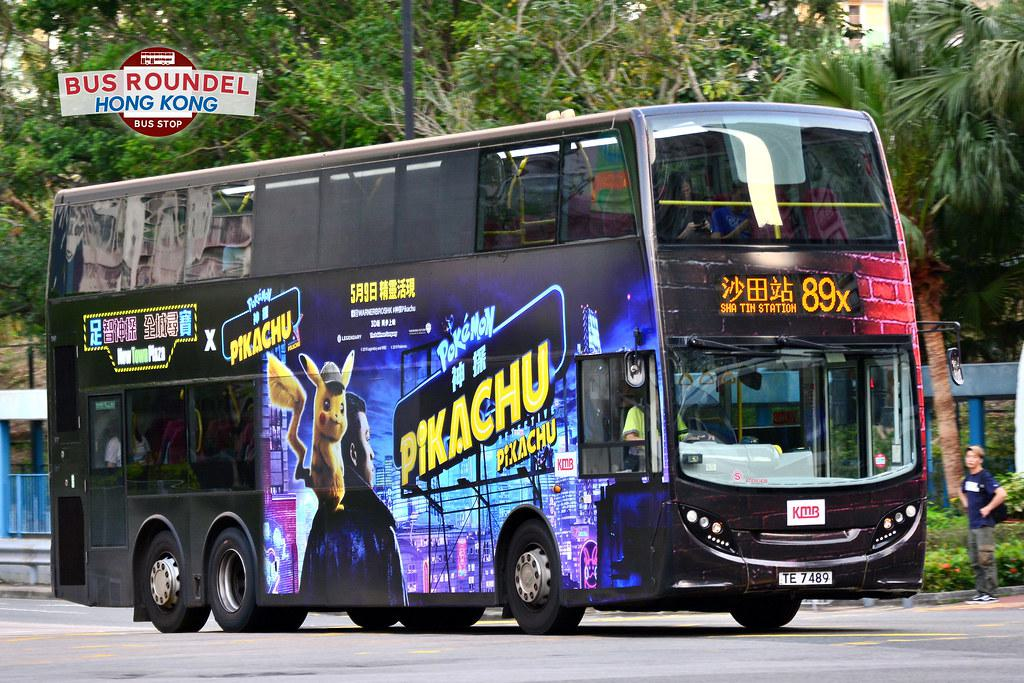Would there be a bus in the image if the bus was not in the picture? No 